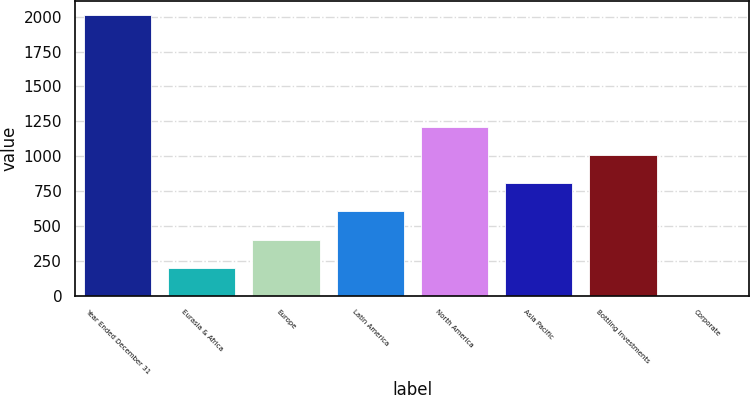Convert chart. <chart><loc_0><loc_0><loc_500><loc_500><bar_chart><fcel>Year Ended December 31<fcel>Eurasia & Africa<fcel>Europe<fcel>Latin America<fcel>North America<fcel>Asia Pacific<fcel>Bottling Investments<fcel>Corporate<nl><fcel>2013<fcel>201.57<fcel>402.84<fcel>604.11<fcel>1207.92<fcel>805.38<fcel>1006.65<fcel>0.3<nl></chart> 